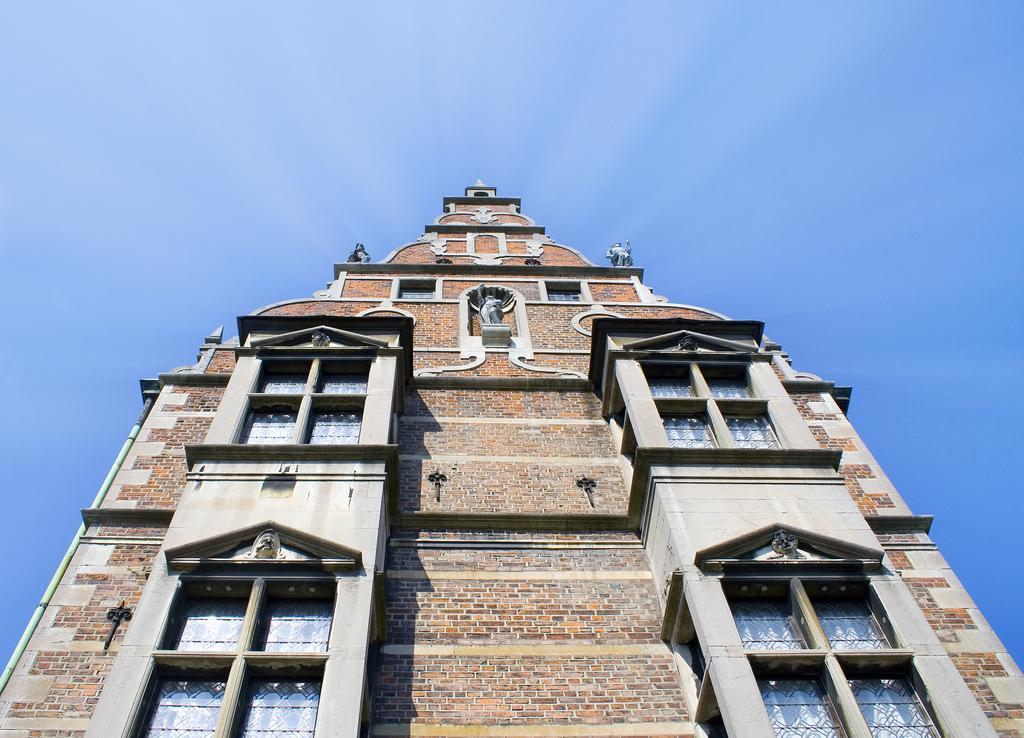How would you summarize this image in a sentence or two? In this picture, we see a building which is made up of bricks. This building has windows. At the top of the picture, we see the sky, which is blue in color. 